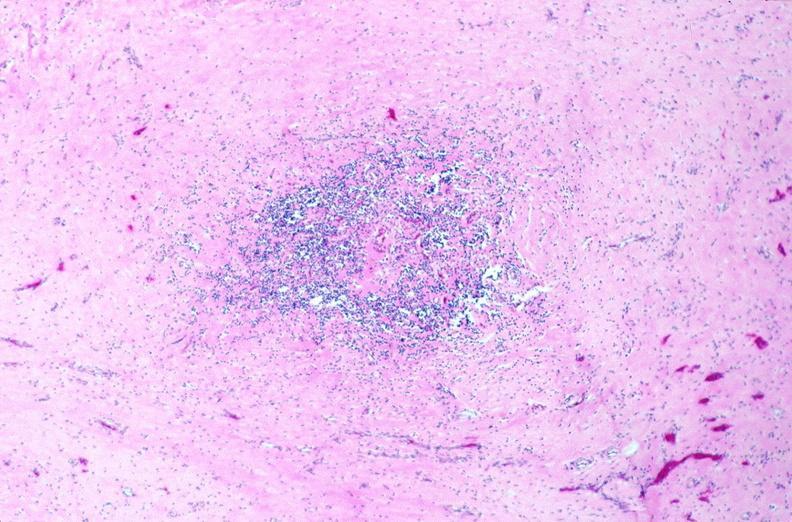what does this image show?
Answer the question using a single word or phrase. Lymph nodes 